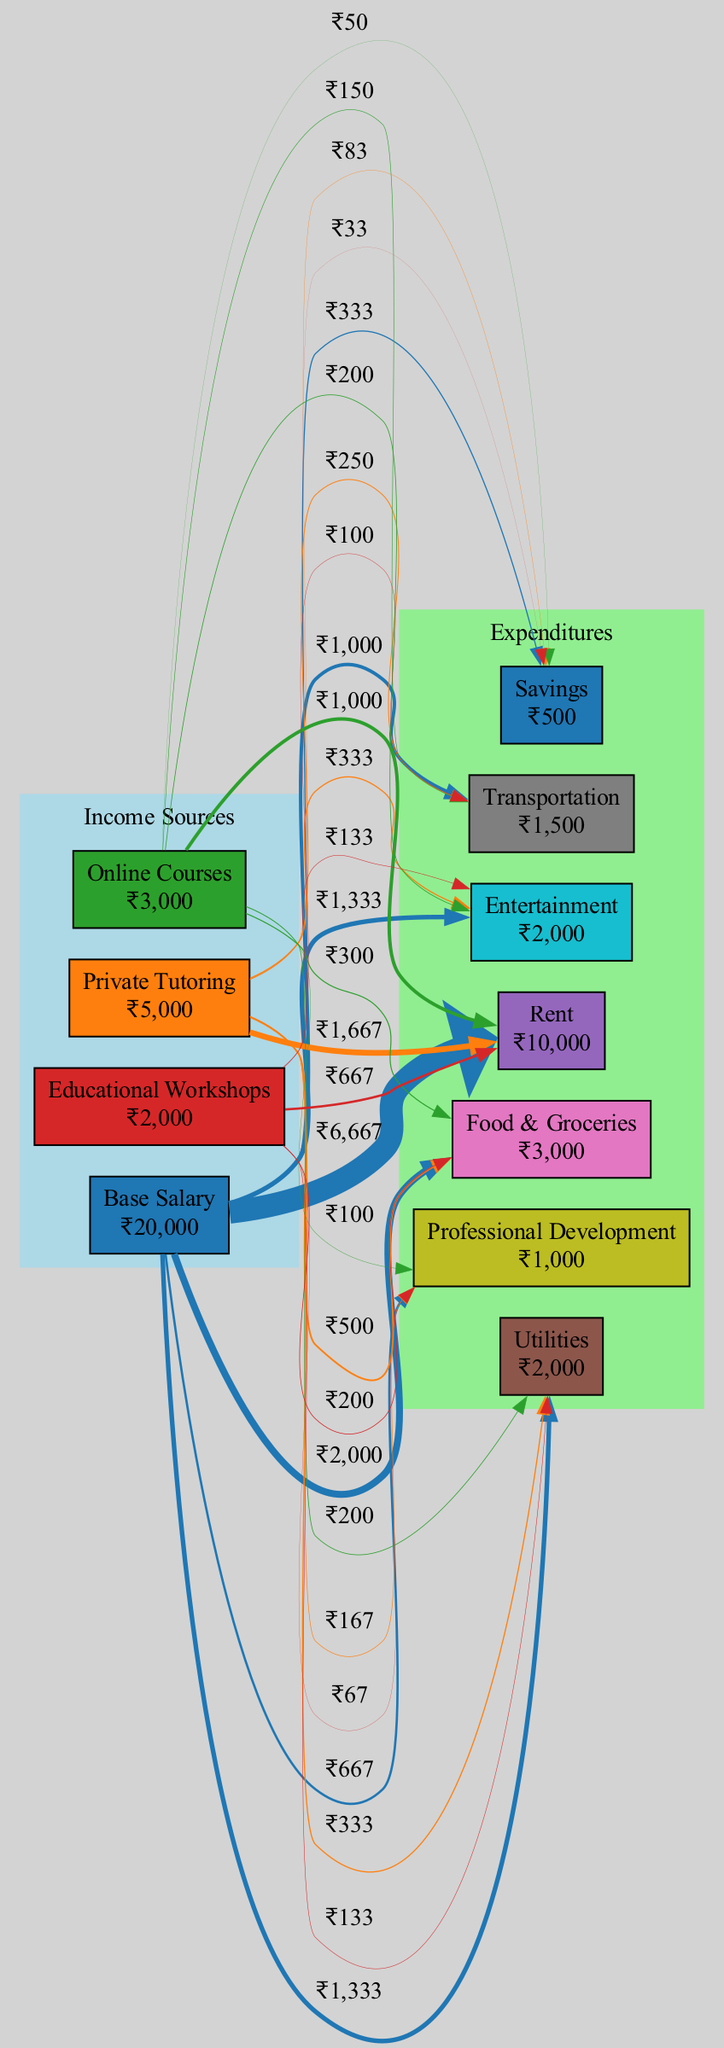What is the total income for the teacher? To find the total income, we need to sum all the income sources shown in the diagram. They include Base Salary (20000), Private Tutoring (5000), Online Courses (3000), and Educational Workshops (2000). Adding these amounts gives us a total of 20000 + 5000 + 3000 + 2000 = 30000.
Answer: 30000 Which expenditure has the highest amount? By reviewing the expenditure categories in the diagram, we can compare their values. The expenditures are Rent (10000), Utilities (2000), Food & Groceries (3000), Transportation (1500), Professional Development (1000), Entertainment (2000), and Savings (500). Rent has the highest value at 10000.
Answer: Rent How much does the teacher spend on Transportation? In the expenditures section of the diagram, we can identify the amount allocated for Transportation, which is specifically stated as 1500.
Answer: 1500 Which income source contributes the least to the total income? To determine the income source with the least contribution, we examine the amounts for each source: Base Salary (20000), Private Tutoring (5000), Online Courses (3000), and Educational Workshops (2000). The least amount shown is for Online Courses at 3000.
Answer: Online Courses What is the total expenditure amount? We calculate the total expenditure by summing all the expenditure categories displayed in the diagram: Rent (10000), Utilities (2000), Food & Groceries (3000), Transportation (1500), Professional Development (1000), Entertainment (2000), and Savings (500). The total is 10000 + 2000 + 3000 + 1500 + 1000 + 2000 + 500 = 20000.
Answer: 20000 Which income source is linked to the highest expenditure? We examine the flow between income sources and expenditures. The Base Salary (20000) contributes to multiple expenditure categories, the highest flow being linked to Rent (10000). Since it's the largest amount coming from the income, it has the highest connection.
Answer: Base Salary What percentage of total income is allocated to Savings? First, we identify the amount spent on Savings, which is 500. The total income is 30000. We then calculate the percentage by dividing the Savings amount by the total income: (500 / 30000) * 100 = 1.67%.
Answer: 1.67% How many unique expenditure categories are present in the diagram? We review each expenditure category listed in the diagram, which are Rent, Utilities, Food & Groceries, Transportation, Professional Development, Entertainment, and Savings. Counting these gives us a total of 7 unique expenditure categories.
Answer: 7 Which source of income flows to the Entertainment expenditure? Observing the flow from the income sources to expenditures, we see that Private Tutoring (5000) has a connection to Entertainment. The label on the edge indicates the amount flowing to that expenditure category.
Answer: Private Tutoring 